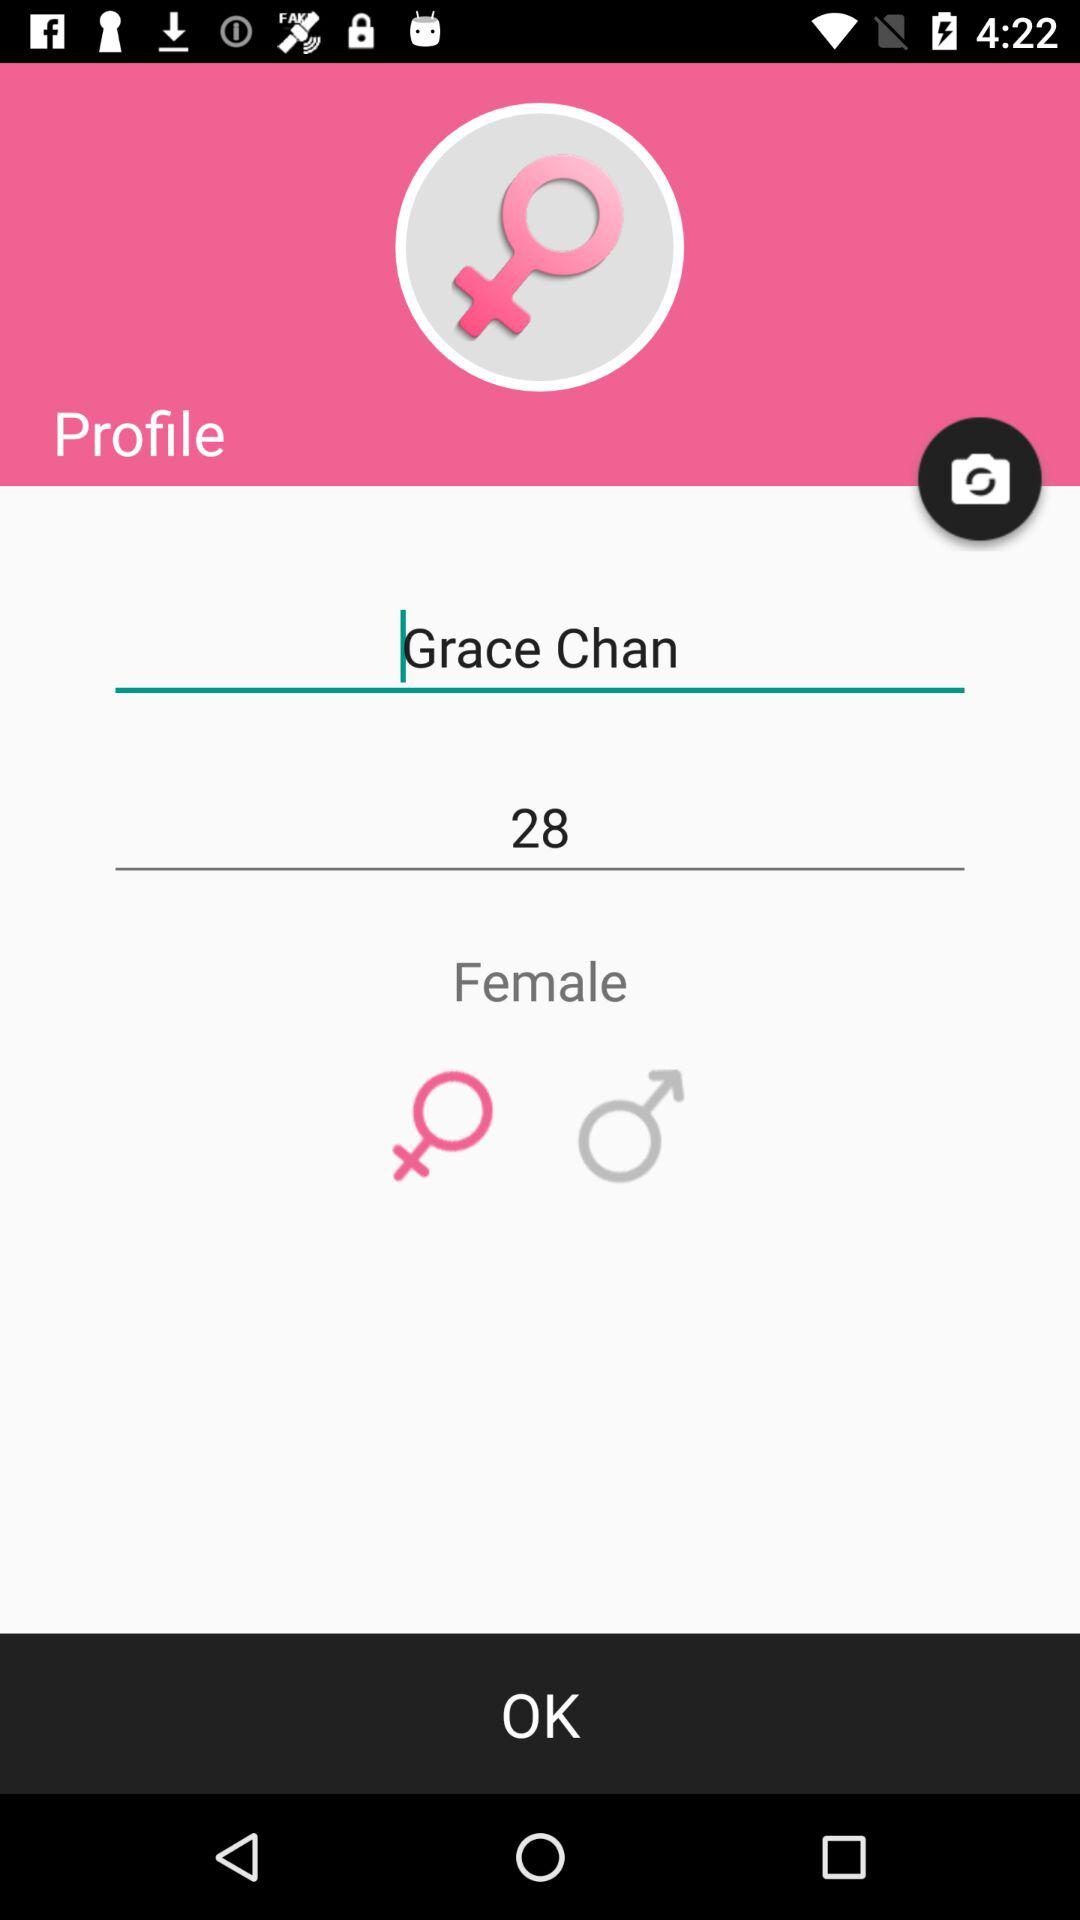What is the gender of the user? The gender of the user is female. 